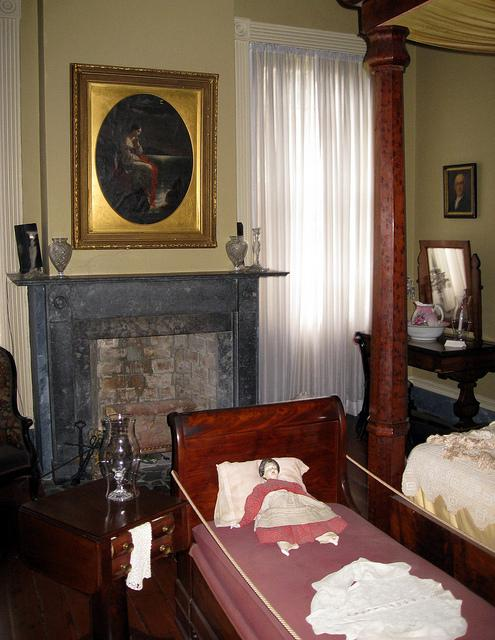What is the black structure against the wall used to contain?

Choices:
A) books
B) pillows
C) fire
D) water fire 